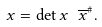Convert formula to latex. <formula><loc_0><loc_0><loc_500><loc_500>x = \det x \ \overline { x } ^ { \# } .</formula> 